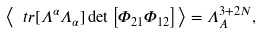Convert formula to latex. <formula><loc_0><loc_0><loc_500><loc_500>\left < \ t r [ \Lambda ^ { \alpha } \Lambda _ { \alpha } ] \det \left [ \Phi _ { 2 1 } \Phi _ { 1 2 } \right ] \right > = \Lambda ^ { 3 + 2 N } _ { A } ,</formula> 